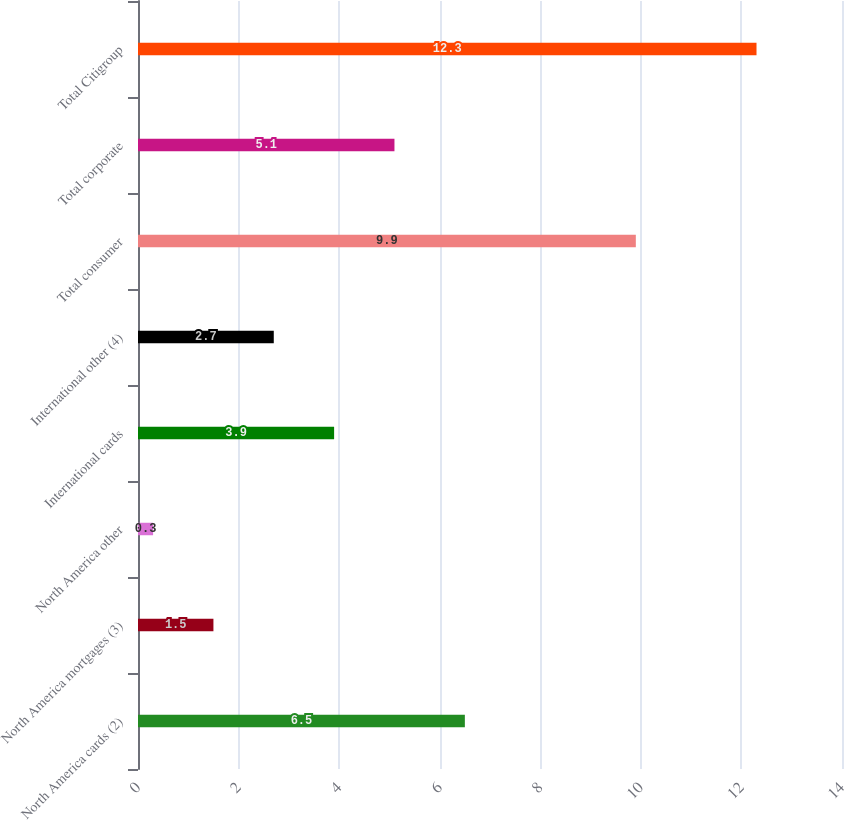<chart> <loc_0><loc_0><loc_500><loc_500><bar_chart><fcel>North America cards (2)<fcel>North America mortgages (3)<fcel>North America other<fcel>International cards<fcel>International other (4)<fcel>Total consumer<fcel>Total corporate<fcel>Total Citigroup<nl><fcel>6.5<fcel>1.5<fcel>0.3<fcel>3.9<fcel>2.7<fcel>9.9<fcel>5.1<fcel>12.3<nl></chart> 